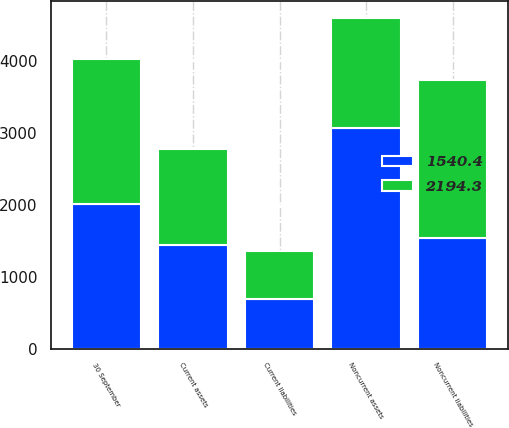Convert chart. <chart><loc_0><loc_0><loc_500><loc_500><stacked_bar_chart><ecel><fcel>30 September<fcel>Current assets<fcel>Noncurrent assets<fcel>Current liabilities<fcel>Noncurrent liabilities<nl><fcel>2194.3<fcel>2017<fcel>1333.2<fcel>1540.4<fcel>666.8<fcel>2194.3<nl><fcel>1540.4<fcel>2016<fcel>1436.7<fcel>3063.3<fcel>694.8<fcel>1540.4<nl></chart> 